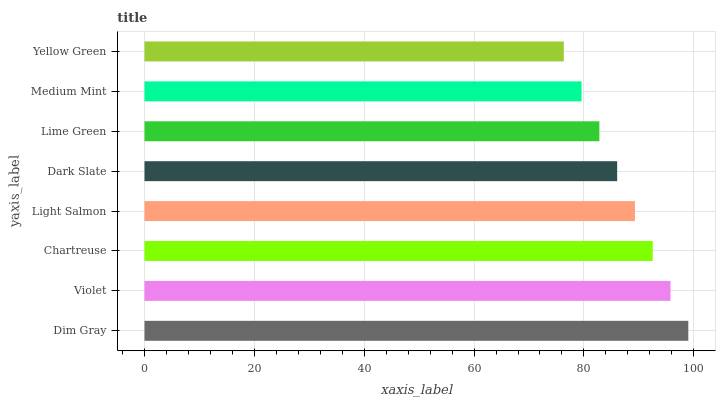Is Yellow Green the minimum?
Answer yes or no. Yes. Is Dim Gray the maximum?
Answer yes or no. Yes. Is Violet the minimum?
Answer yes or no. No. Is Violet the maximum?
Answer yes or no. No. Is Dim Gray greater than Violet?
Answer yes or no. Yes. Is Violet less than Dim Gray?
Answer yes or no. Yes. Is Violet greater than Dim Gray?
Answer yes or no. No. Is Dim Gray less than Violet?
Answer yes or no. No. Is Light Salmon the high median?
Answer yes or no. Yes. Is Dark Slate the low median?
Answer yes or no. Yes. Is Lime Green the high median?
Answer yes or no. No. Is Violet the low median?
Answer yes or no. No. 